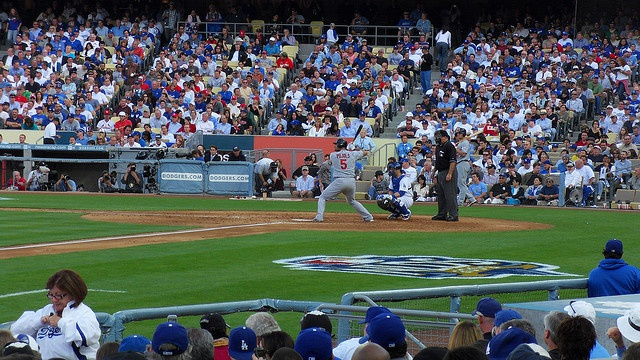Describe the objects in this image and their specific colors. I can see people in black, gray, navy, and brown tones, people in black, darkgray, and gray tones, people in black, navy, darkblue, and blue tones, people in black, gray, and brown tones, and people in black, navy, lavender, and gray tones in this image. 